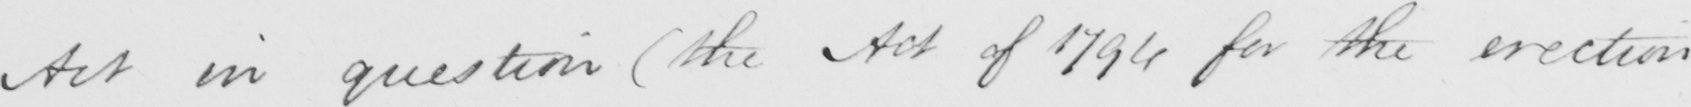Please provide the text content of this handwritten line. Act in question  ( the Act of 1794 for the erection 